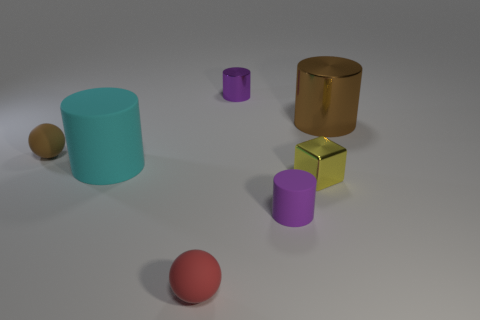Is there anything else of the same color as the small rubber cylinder?
Make the answer very short. Yes. What is the material of the other cylinder that is the same color as the tiny rubber cylinder?
Keep it short and to the point. Metal. How many small cylinders are the same color as the big metallic cylinder?
Your answer should be compact. 0. What shape is the small purple object that is to the left of the small purple object that is in front of the big brown shiny cylinder?
Offer a very short reply. Cylinder. Are there any big metallic objects that have the same shape as the big matte object?
Offer a terse response. Yes. Does the tiny matte cylinder have the same color as the small thing behind the big brown shiny object?
Ensure brevity in your answer.  Yes. Are there any yellow objects that have the same size as the purple matte object?
Your answer should be very brief. Yes. Is the yellow cube made of the same material as the tiny purple thing to the right of the purple shiny cylinder?
Provide a succinct answer. No. Is the number of green metal cylinders greater than the number of yellow objects?
Your answer should be very brief. No. How many blocks are small brown shiny things or purple shiny objects?
Offer a terse response. 0. 